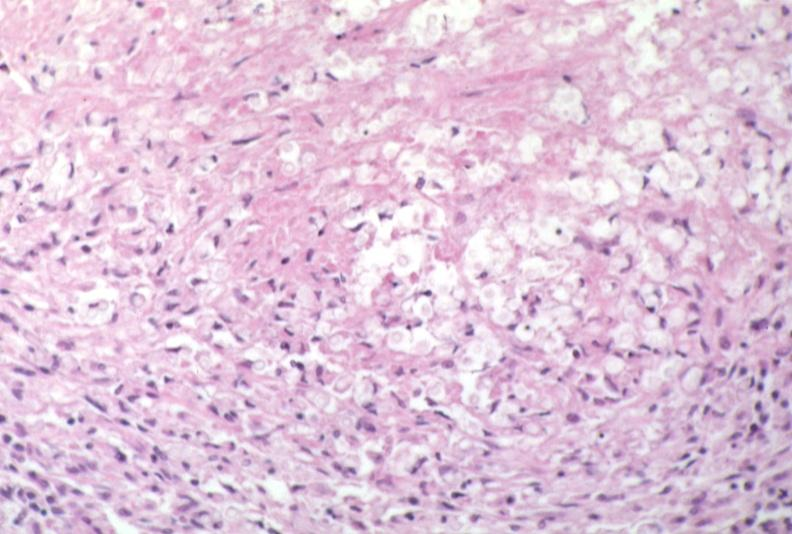what does this image show?
Answer the question using a single word or phrase. Lymph node 